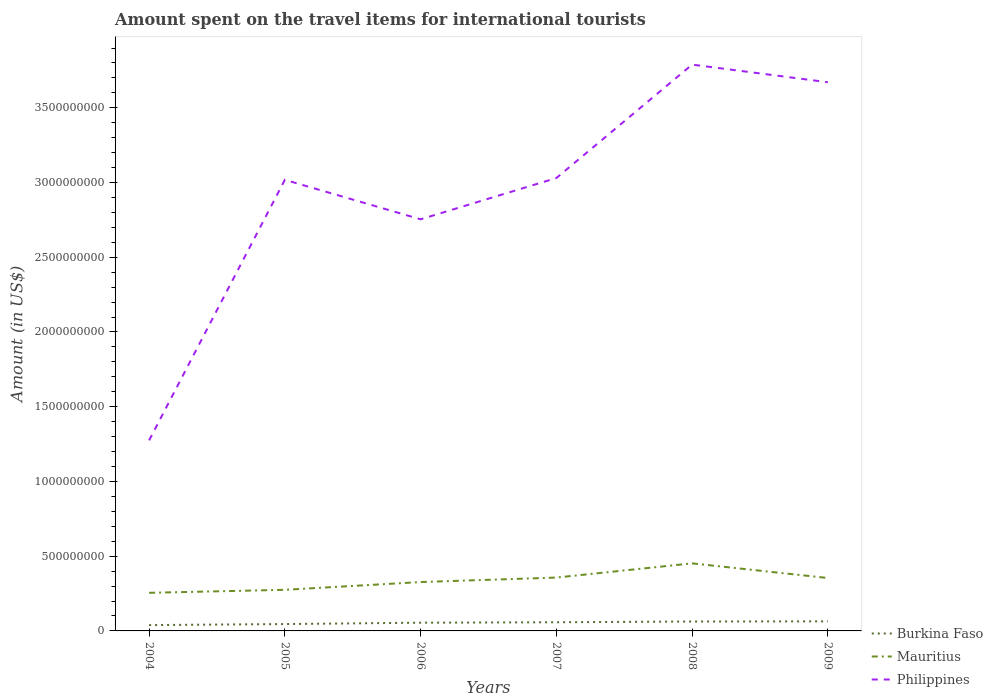How many different coloured lines are there?
Provide a succinct answer. 3. Is the number of lines equal to the number of legend labels?
Provide a short and direct response. Yes. Across all years, what is the maximum amount spent on the travel items for international tourists in Philippines?
Your answer should be very brief. 1.28e+09. What is the total amount spent on the travel items for international tourists in Mauritius in the graph?
Provide a succinct answer. -1.25e+08. What is the difference between the highest and the second highest amount spent on the travel items for international tourists in Burkina Faso?
Give a very brief answer. 2.50e+07. What is the difference between the highest and the lowest amount spent on the travel items for international tourists in Philippines?
Your answer should be very brief. 4. Is the amount spent on the travel items for international tourists in Philippines strictly greater than the amount spent on the travel items for international tourists in Burkina Faso over the years?
Give a very brief answer. No. Are the values on the major ticks of Y-axis written in scientific E-notation?
Your answer should be very brief. No. Does the graph contain any zero values?
Offer a terse response. No. Does the graph contain grids?
Offer a terse response. No. What is the title of the graph?
Keep it short and to the point. Amount spent on the travel items for international tourists. What is the label or title of the X-axis?
Provide a short and direct response. Years. What is the Amount (in US$) of Burkina Faso in 2004?
Offer a very short reply. 3.90e+07. What is the Amount (in US$) of Mauritius in 2004?
Your answer should be very brief. 2.55e+08. What is the Amount (in US$) of Philippines in 2004?
Give a very brief answer. 1.28e+09. What is the Amount (in US$) of Burkina Faso in 2005?
Keep it short and to the point. 4.60e+07. What is the Amount (in US$) of Mauritius in 2005?
Ensure brevity in your answer.  2.75e+08. What is the Amount (in US$) in Philippines in 2005?
Provide a succinct answer. 3.02e+09. What is the Amount (in US$) of Burkina Faso in 2006?
Provide a succinct answer. 5.50e+07. What is the Amount (in US$) in Mauritius in 2006?
Give a very brief answer. 3.27e+08. What is the Amount (in US$) in Philippines in 2006?
Your answer should be compact. 2.75e+09. What is the Amount (in US$) of Burkina Faso in 2007?
Keep it short and to the point. 5.80e+07. What is the Amount (in US$) in Mauritius in 2007?
Your response must be concise. 3.57e+08. What is the Amount (in US$) of Philippines in 2007?
Your answer should be compact. 3.03e+09. What is the Amount (in US$) of Burkina Faso in 2008?
Give a very brief answer. 6.30e+07. What is the Amount (in US$) of Mauritius in 2008?
Offer a very short reply. 4.52e+08. What is the Amount (in US$) in Philippines in 2008?
Offer a terse response. 3.79e+09. What is the Amount (in US$) of Burkina Faso in 2009?
Offer a terse response. 6.40e+07. What is the Amount (in US$) in Mauritius in 2009?
Keep it short and to the point. 3.54e+08. What is the Amount (in US$) in Philippines in 2009?
Make the answer very short. 3.67e+09. Across all years, what is the maximum Amount (in US$) of Burkina Faso?
Your answer should be compact. 6.40e+07. Across all years, what is the maximum Amount (in US$) of Mauritius?
Give a very brief answer. 4.52e+08. Across all years, what is the maximum Amount (in US$) in Philippines?
Your answer should be very brief. 3.79e+09. Across all years, what is the minimum Amount (in US$) of Burkina Faso?
Your answer should be compact. 3.90e+07. Across all years, what is the minimum Amount (in US$) in Mauritius?
Your answer should be very brief. 2.55e+08. Across all years, what is the minimum Amount (in US$) in Philippines?
Your response must be concise. 1.28e+09. What is the total Amount (in US$) of Burkina Faso in the graph?
Keep it short and to the point. 3.25e+08. What is the total Amount (in US$) in Mauritius in the graph?
Provide a succinct answer. 2.02e+09. What is the total Amount (in US$) of Philippines in the graph?
Your response must be concise. 1.75e+1. What is the difference between the Amount (in US$) in Burkina Faso in 2004 and that in 2005?
Ensure brevity in your answer.  -7.00e+06. What is the difference between the Amount (in US$) in Mauritius in 2004 and that in 2005?
Your answer should be compact. -2.00e+07. What is the difference between the Amount (in US$) in Philippines in 2004 and that in 2005?
Offer a very short reply. -1.74e+09. What is the difference between the Amount (in US$) of Burkina Faso in 2004 and that in 2006?
Keep it short and to the point. -1.60e+07. What is the difference between the Amount (in US$) in Mauritius in 2004 and that in 2006?
Offer a very short reply. -7.20e+07. What is the difference between the Amount (in US$) of Philippines in 2004 and that in 2006?
Give a very brief answer. -1.48e+09. What is the difference between the Amount (in US$) of Burkina Faso in 2004 and that in 2007?
Ensure brevity in your answer.  -1.90e+07. What is the difference between the Amount (in US$) in Mauritius in 2004 and that in 2007?
Give a very brief answer. -1.02e+08. What is the difference between the Amount (in US$) in Philippines in 2004 and that in 2007?
Your response must be concise. -1.76e+09. What is the difference between the Amount (in US$) of Burkina Faso in 2004 and that in 2008?
Your answer should be compact. -2.40e+07. What is the difference between the Amount (in US$) in Mauritius in 2004 and that in 2008?
Offer a terse response. -1.97e+08. What is the difference between the Amount (in US$) in Philippines in 2004 and that in 2008?
Give a very brief answer. -2.51e+09. What is the difference between the Amount (in US$) of Burkina Faso in 2004 and that in 2009?
Offer a very short reply. -2.50e+07. What is the difference between the Amount (in US$) of Mauritius in 2004 and that in 2009?
Your response must be concise. -9.90e+07. What is the difference between the Amount (in US$) of Philippines in 2004 and that in 2009?
Provide a short and direct response. -2.40e+09. What is the difference between the Amount (in US$) in Burkina Faso in 2005 and that in 2006?
Keep it short and to the point. -9.00e+06. What is the difference between the Amount (in US$) of Mauritius in 2005 and that in 2006?
Your answer should be compact. -5.20e+07. What is the difference between the Amount (in US$) in Philippines in 2005 and that in 2006?
Give a very brief answer. 2.64e+08. What is the difference between the Amount (in US$) in Burkina Faso in 2005 and that in 2007?
Provide a succinct answer. -1.20e+07. What is the difference between the Amount (in US$) of Mauritius in 2005 and that in 2007?
Offer a very short reply. -8.20e+07. What is the difference between the Amount (in US$) in Philippines in 2005 and that in 2007?
Ensure brevity in your answer.  -1.20e+07. What is the difference between the Amount (in US$) of Burkina Faso in 2005 and that in 2008?
Give a very brief answer. -1.70e+07. What is the difference between the Amount (in US$) of Mauritius in 2005 and that in 2008?
Your answer should be very brief. -1.77e+08. What is the difference between the Amount (in US$) in Philippines in 2005 and that in 2008?
Provide a short and direct response. -7.71e+08. What is the difference between the Amount (in US$) in Burkina Faso in 2005 and that in 2009?
Keep it short and to the point. -1.80e+07. What is the difference between the Amount (in US$) of Mauritius in 2005 and that in 2009?
Your answer should be compact. -7.90e+07. What is the difference between the Amount (in US$) of Philippines in 2005 and that in 2009?
Provide a short and direct response. -6.53e+08. What is the difference between the Amount (in US$) in Burkina Faso in 2006 and that in 2007?
Keep it short and to the point. -3.00e+06. What is the difference between the Amount (in US$) of Mauritius in 2006 and that in 2007?
Make the answer very short. -3.00e+07. What is the difference between the Amount (in US$) of Philippines in 2006 and that in 2007?
Keep it short and to the point. -2.76e+08. What is the difference between the Amount (in US$) of Burkina Faso in 2006 and that in 2008?
Give a very brief answer. -8.00e+06. What is the difference between the Amount (in US$) in Mauritius in 2006 and that in 2008?
Provide a short and direct response. -1.25e+08. What is the difference between the Amount (in US$) in Philippines in 2006 and that in 2008?
Provide a succinct answer. -1.04e+09. What is the difference between the Amount (in US$) in Burkina Faso in 2006 and that in 2009?
Ensure brevity in your answer.  -9.00e+06. What is the difference between the Amount (in US$) in Mauritius in 2006 and that in 2009?
Keep it short and to the point. -2.70e+07. What is the difference between the Amount (in US$) of Philippines in 2006 and that in 2009?
Your response must be concise. -9.17e+08. What is the difference between the Amount (in US$) in Burkina Faso in 2007 and that in 2008?
Your answer should be very brief. -5.00e+06. What is the difference between the Amount (in US$) of Mauritius in 2007 and that in 2008?
Offer a terse response. -9.50e+07. What is the difference between the Amount (in US$) of Philippines in 2007 and that in 2008?
Ensure brevity in your answer.  -7.59e+08. What is the difference between the Amount (in US$) of Burkina Faso in 2007 and that in 2009?
Offer a very short reply. -6.00e+06. What is the difference between the Amount (in US$) in Philippines in 2007 and that in 2009?
Ensure brevity in your answer.  -6.41e+08. What is the difference between the Amount (in US$) of Burkina Faso in 2008 and that in 2009?
Your response must be concise. -1.00e+06. What is the difference between the Amount (in US$) in Mauritius in 2008 and that in 2009?
Ensure brevity in your answer.  9.80e+07. What is the difference between the Amount (in US$) in Philippines in 2008 and that in 2009?
Make the answer very short. 1.18e+08. What is the difference between the Amount (in US$) in Burkina Faso in 2004 and the Amount (in US$) in Mauritius in 2005?
Provide a short and direct response. -2.36e+08. What is the difference between the Amount (in US$) in Burkina Faso in 2004 and the Amount (in US$) in Philippines in 2005?
Offer a very short reply. -2.98e+09. What is the difference between the Amount (in US$) of Mauritius in 2004 and the Amount (in US$) of Philippines in 2005?
Make the answer very short. -2.76e+09. What is the difference between the Amount (in US$) in Burkina Faso in 2004 and the Amount (in US$) in Mauritius in 2006?
Ensure brevity in your answer.  -2.88e+08. What is the difference between the Amount (in US$) of Burkina Faso in 2004 and the Amount (in US$) of Philippines in 2006?
Make the answer very short. -2.72e+09. What is the difference between the Amount (in US$) in Mauritius in 2004 and the Amount (in US$) in Philippines in 2006?
Keep it short and to the point. -2.50e+09. What is the difference between the Amount (in US$) of Burkina Faso in 2004 and the Amount (in US$) of Mauritius in 2007?
Make the answer very short. -3.18e+08. What is the difference between the Amount (in US$) of Burkina Faso in 2004 and the Amount (in US$) of Philippines in 2007?
Offer a terse response. -2.99e+09. What is the difference between the Amount (in US$) in Mauritius in 2004 and the Amount (in US$) in Philippines in 2007?
Make the answer very short. -2.78e+09. What is the difference between the Amount (in US$) of Burkina Faso in 2004 and the Amount (in US$) of Mauritius in 2008?
Your response must be concise. -4.13e+08. What is the difference between the Amount (in US$) in Burkina Faso in 2004 and the Amount (in US$) in Philippines in 2008?
Your answer should be very brief. -3.75e+09. What is the difference between the Amount (in US$) in Mauritius in 2004 and the Amount (in US$) in Philippines in 2008?
Provide a short and direct response. -3.53e+09. What is the difference between the Amount (in US$) of Burkina Faso in 2004 and the Amount (in US$) of Mauritius in 2009?
Provide a short and direct response. -3.15e+08. What is the difference between the Amount (in US$) in Burkina Faso in 2004 and the Amount (in US$) in Philippines in 2009?
Your response must be concise. -3.63e+09. What is the difference between the Amount (in US$) of Mauritius in 2004 and the Amount (in US$) of Philippines in 2009?
Make the answer very short. -3.42e+09. What is the difference between the Amount (in US$) of Burkina Faso in 2005 and the Amount (in US$) of Mauritius in 2006?
Make the answer very short. -2.81e+08. What is the difference between the Amount (in US$) of Burkina Faso in 2005 and the Amount (in US$) of Philippines in 2006?
Your answer should be very brief. -2.71e+09. What is the difference between the Amount (in US$) in Mauritius in 2005 and the Amount (in US$) in Philippines in 2006?
Ensure brevity in your answer.  -2.48e+09. What is the difference between the Amount (in US$) in Burkina Faso in 2005 and the Amount (in US$) in Mauritius in 2007?
Your answer should be compact. -3.11e+08. What is the difference between the Amount (in US$) in Burkina Faso in 2005 and the Amount (in US$) in Philippines in 2007?
Ensure brevity in your answer.  -2.98e+09. What is the difference between the Amount (in US$) in Mauritius in 2005 and the Amount (in US$) in Philippines in 2007?
Provide a short and direct response. -2.76e+09. What is the difference between the Amount (in US$) of Burkina Faso in 2005 and the Amount (in US$) of Mauritius in 2008?
Provide a succinct answer. -4.06e+08. What is the difference between the Amount (in US$) in Burkina Faso in 2005 and the Amount (in US$) in Philippines in 2008?
Offer a very short reply. -3.74e+09. What is the difference between the Amount (in US$) of Mauritius in 2005 and the Amount (in US$) of Philippines in 2008?
Offer a terse response. -3.51e+09. What is the difference between the Amount (in US$) of Burkina Faso in 2005 and the Amount (in US$) of Mauritius in 2009?
Offer a terse response. -3.08e+08. What is the difference between the Amount (in US$) of Burkina Faso in 2005 and the Amount (in US$) of Philippines in 2009?
Provide a short and direct response. -3.62e+09. What is the difference between the Amount (in US$) in Mauritius in 2005 and the Amount (in US$) in Philippines in 2009?
Your response must be concise. -3.40e+09. What is the difference between the Amount (in US$) in Burkina Faso in 2006 and the Amount (in US$) in Mauritius in 2007?
Give a very brief answer. -3.02e+08. What is the difference between the Amount (in US$) of Burkina Faso in 2006 and the Amount (in US$) of Philippines in 2007?
Offer a terse response. -2.98e+09. What is the difference between the Amount (in US$) in Mauritius in 2006 and the Amount (in US$) in Philippines in 2007?
Your answer should be compact. -2.70e+09. What is the difference between the Amount (in US$) of Burkina Faso in 2006 and the Amount (in US$) of Mauritius in 2008?
Your answer should be very brief. -3.97e+08. What is the difference between the Amount (in US$) in Burkina Faso in 2006 and the Amount (in US$) in Philippines in 2008?
Provide a succinct answer. -3.73e+09. What is the difference between the Amount (in US$) in Mauritius in 2006 and the Amount (in US$) in Philippines in 2008?
Provide a succinct answer. -3.46e+09. What is the difference between the Amount (in US$) of Burkina Faso in 2006 and the Amount (in US$) of Mauritius in 2009?
Offer a very short reply. -2.99e+08. What is the difference between the Amount (in US$) of Burkina Faso in 2006 and the Amount (in US$) of Philippines in 2009?
Provide a succinct answer. -3.62e+09. What is the difference between the Amount (in US$) of Mauritius in 2006 and the Amount (in US$) of Philippines in 2009?
Provide a succinct answer. -3.34e+09. What is the difference between the Amount (in US$) in Burkina Faso in 2007 and the Amount (in US$) in Mauritius in 2008?
Your answer should be very brief. -3.94e+08. What is the difference between the Amount (in US$) in Burkina Faso in 2007 and the Amount (in US$) in Philippines in 2008?
Provide a succinct answer. -3.73e+09. What is the difference between the Amount (in US$) of Mauritius in 2007 and the Amount (in US$) of Philippines in 2008?
Offer a very short reply. -3.43e+09. What is the difference between the Amount (in US$) in Burkina Faso in 2007 and the Amount (in US$) in Mauritius in 2009?
Ensure brevity in your answer.  -2.96e+08. What is the difference between the Amount (in US$) of Burkina Faso in 2007 and the Amount (in US$) of Philippines in 2009?
Give a very brief answer. -3.61e+09. What is the difference between the Amount (in US$) of Mauritius in 2007 and the Amount (in US$) of Philippines in 2009?
Offer a terse response. -3.31e+09. What is the difference between the Amount (in US$) in Burkina Faso in 2008 and the Amount (in US$) in Mauritius in 2009?
Your answer should be compact. -2.91e+08. What is the difference between the Amount (in US$) in Burkina Faso in 2008 and the Amount (in US$) in Philippines in 2009?
Make the answer very short. -3.61e+09. What is the difference between the Amount (in US$) of Mauritius in 2008 and the Amount (in US$) of Philippines in 2009?
Your answer should be compact. -3.22e+09. What is the average Amount (in US$) of Burkina Faso per year?
Keep it short and to the point. 5.42e+07. What is the average Amount (in US$) in Mauritius per year?
Give a very brief answer. 3.37e+08. What is the average Amount (in US$) of Philippines per year?
Offer a terse response. 2.92e+09. In the year 2004, what is the difference between the Amount (in US$) in Burkina Faso and Amount (in US$) in Mauritius?
Offer a very short reply. -2.16e+08. In the year 2004, what is the difference between the Amount (in US$) in Burkina Faso and Amount (in US$) in Philippines?
Provide a succinct answer. -1.24e+09. In the year 2004, what is the difference between the Amount (in US$) in Mauritius and Amount (in US$) in Philippines?
Your answer should be very brief. -1.02e+09. In the year 2005, what is the difference between the Amount (in US$) in Burkina Faso and Amount (in US$) in Mauritius?
Your answer should be very brief. -2.29e+08. In the year 2005, what is the difference between the Amount (in US$) of Burkina Faso and Amount (in US$) of Philippines?
Keep it short and to the point. -2.97e+09. In the year 2005, what is the difference between the Amount (in US$) in Mauritius and Amount (in US$) in Philippines?
Provide a succinct answer. -2.74e+09. In the year 2006, what is the difference between the Amount (in US$) of Burkina Faso and Amount (in US$) of Mauritius?
Your answer should be compact. -2.72e+08. In the year 2006, what is the difference between the Amount (in US$) of Burkina Faso and Amount (in US$) of Philippines?
Offer a terse response. -2.70e+09. In the year 2006, what is the difference between the Amount (in US$) of Mauritius and Amount (in US$) of Philippines?
Give a very brief answer. -2.43e+09. In the year 2007, what is the difference between the Amount (in US$) in Burkina Faso and Amount (in US$) in Mauritius?
Your response must be concise. -2.99e+08. In the year 2007, what is the difference between the Amount (in US$) of Burkina Faso and Amount (in US$) of Philippines?
Provide a succinct answer. -2.97e+09. In the year 2007, what is the difference between the Amount (in US$) of Mauritius and Amount (in US$) of Philippines?
Keep it short and to the point. -2.67e+09. In the year 2008, what is the difference between the Amount (in US$) of Burkina Faso and Amount (in US$) of Mauritius?
Make the answer very short. -3.89e+08. In the year 2008, what is the difference between the Amount (in US$) of Burkina Faso and Amount (in US$) of Philippines?
Your answer should be compact. -3.73e+09. In the year 2008, what is the difference between the Amount (in US$) in Mauritius and Amount (in US$) in Philippines?
Offer a very short reply. -3.34e+09. In the year 2009, what is the difference between the Amount (in US$) in Burkina Faso and Amount (in US$) in Mauritius?
Offer a very short reply. -2.90e+08. In the year 2009, what is the difference between the Amount (in US$) of Burkina Faso and Amount (in US$) of Philippines?
Offer a terse response. -3.61e+09. In the year 2009, what is the difference between the Amount (in US$) in Mauritius and Amount (in US$) in Philippines?
Your answer should be compact. -3.32e+09. What is the ratio of the Amount (in US$) of Burkina Faso in 2004 to that in 2005?
Ensure brevity in your answer.  0.85. What is the ratio of the Amount (in US$) of Mauritius in 2004 to that in 2005?
Offer a terse response. 0.93. What is the ratio of the Amount (in US$) of Philippines in 2004 to that in 2005?
Your answer should be compact. 0.42. What is the ratio of the Amount (in US$) in Burkina Faso in 2004 to that in 2006?
Offer a very short reply. 0.71. What is the ratio of the Amount (in US$) in Mauritius in 2004 to that in 2006?
Offer a terse response. 0.78. What is the ratio of the Amount (in US$) in Philippines in 2004 to that in 2006?
Your response must be concise. 0.46. What is the ratio of the Amount (in US$) in Burkina Faso in 2004 to that in 2007?
Provide a short and direct response. 0.67. What is the ratio of the Amount (in US$) of Mauritius in 2004 to that in 2007?
Offer a terse response. 0.71. What is the ratio of the Amount (in US$) of Philippines in 2004 to that in 2007?
Give a very brief answer. 0.42. What is the ratio of the Amount (in US$) of Burkina Faso in 2004 to that in 2008?
Your answer should be very brief. 0.62. What is the ratio of the Amount (in US$) of Mauritius in 2004 to that in 2008?
Your response must be concise. 0.56. What is the ratio of the Amount (in US$) in Philippines in 2004 to that in 2008?
Your response must be concise. 0.34. What is the ratio of the Amount (in US$) of Burkina Faso in 2004 to that in 2009?
Your answer should be very brief. 0.61. What is the ratio of the Amount (in US$) of Mauritius in 2004 to that in 2009?
Make the answer very short. 0.72. What is the ratio of the Amount (in US$) in Philippines in 2004 to that in 2009?
Ensure brevity in your answer.  0.35. What is the ratio of the Amount (in US$) in Burkina Faso in 2005 to that in 2006?
Your answer should be very brief. 0.84. What is the ratio of the Amount (in US$) of Mauritius in 2005 to that in 2006?
Your response must be concise. 0.84. What is the ratio of the Amount (in US$) in Philippines in 2005 to that in 2006?
Offer a very short reply. 1.1. What is the ratio of the Amount (in US$) of Burkina Faso in 2005 to that in 2007?
Provide a short and direct response. 0.79. What is the ratio of the Amount (in US$) in Mauritius in 2005 to that in 2007?
Keep it short and to the point. 0.77. What is the ratio of the Amount (in US$) in Burkina Faso in 2005 to that in 2008?
Ensure brevity in your answer.  0.73. What is the ratio of the Amount (in US$) of Mauritius in 2005 to that in 2008?
Offer a terse response. 0.61. What is the ratio of the Amount (in US$) in Philippines in 2005 to that in 2008?
Keep it short and to the point. 0.8. What is the ratio of the Amount (in US$) in Burkina Faso in 2005 to that in 2009?
Offer a very short reply. 0.72. What is the ratio of the Amount (in US$) in Mauritius in 2005 to that in 2009?
Offer a very short reply. 0.78. What is the ratio of the Amount (in US$) of Philippines in 2005 to that in 2009?
Offer a very short reply. 0.82. What is the ratio of the Amount (in US$) in Burkina Faso in 2006 to that in 2007?
Your answer should be very brief. 0.95. What is the ratio of the Amount (in US$) in Mauritius in 2006 to that in 2007?
Your answer should be very brief. 0.92. What is the ratio of the Amount (in US$) of Philippines in 2006 to that in 2007?
Offer a very short reply. 0.91. What is the ratio of the Amount (in US$) in Burkina Faso in 2006 to that in 2008?
Give a very brief answer. 0.87. What is the ratio of the Amount (in US$) of Mauritius in 2006 to that in 2008?
Ensure brevity in your answer.  0.72. What is the ratio of the Amount (in US$) in Philippines in 2006 to that in 2008?
Keep it short and to the point. 0.73. What is the ratio of the Amount (in US$) of Burkina Faso in 2006 to that in 2009?
Your answer should be compact. 0.86. What is the ratio of the Amount (in US$) of Mauritius in 2006 to that in 2009?
Your response must be concise. 0.92. What is the ratio of the Amount (in US$) in Philippines in 2006 to that in 2009?
Provide a succinct answer. 0.75. What is the ratio of the Amount (in US$) of Burkina Faso in 2007 to that in 2008?
Ensure brevity in your answer.  0.92. What is the ratio of the Amount (in US$) of Mauritius in 2007 to that in 2008?
Provide a short and direct response. 0.79. What is the ratio of the Amount (in US$) in Philippines in 2007 to that in 2008?
Provide a short and direct response. 0.8. What is the ratio of the Amount (in US$) of Burkina Faso in 2007 to that in 2009?
Your answer should be compact. 0.91. What is the ratio of the Amount (in US$) in Mauritius in 2007 to that in 2009?
Your answer should be very brief. 1.01. What is the ratio of the Amount (in US$) in Philippines in 2007 to that in 2009?
Keep it short and to the point. 0.83. What is the ratio of the Amount (in US$) of Burkina Faso in 2008 to that in 2009?
Offer a terse response. 0.98. What is the ratio of the Amount (in US$) in Mauritius in 2008 to that in 2009?
Keep it short and to the point. 1.28. What is the ratio of the Amount (in US$) in Philippines in 2008 to that in 2009?
Offer a terse response. 1.03. What is the difference between the highest and the second highest Amount (in US$) of Burkina Faso?
Your response must be concise. 1.00e+06. What is the difference between the highest and the second highest Amount (in US$) in Mauritius?
Offer a terse response. 9.50e+07. What is the difference between the highest and the second highest Amount (in US$) in Philippines?
Keep it short and to the point. 1.18e+08. What is the difference between the highest and the lowest Amount (in US$) of Burkina Faso?
Keep it short and to the point. 2.50e+07. What is the difference between the highest and the lowest Amount (in US$) in Mauritius?
Your answer should be compact. 1.97e+08. What is the difference between the highest and the lowest Amount (in US$) in Philippines?
Your answer should be compact. 2.51e+09. 